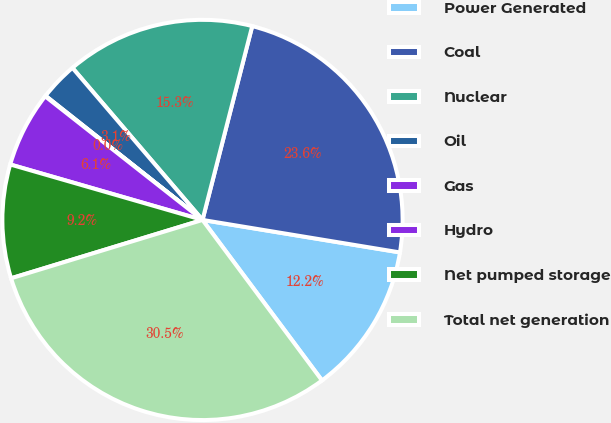<chart> <loc_0><loc_0><loc_500><loc_500><pie_chart><fcel>Power Generated<fcel>Coal<fcel>Nuclear<fcel>Oil<fcel>Gas<fcel>Hydro<fcel>Net pumped storage<fcel>Total net generation<nl><fcel>12.22%<fcel>23.6%<fcel>15.26%<fcel>3.09%<fcel>0.05%<fcel>6.13%<fcel>9.18%<fcel>30.48%<nl></chart> 